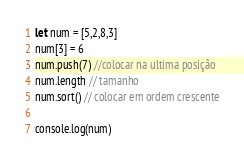<code> <loc_0><loc_0><loc_500><loc_500><_JavaScript_>let num = [5,2,8,3]
num[3] = 6
num.push(7) //colocar na ultima posição
num.length // tamanho
num.sort() // colocar em ordem crescente

console.log(num)

</code> 